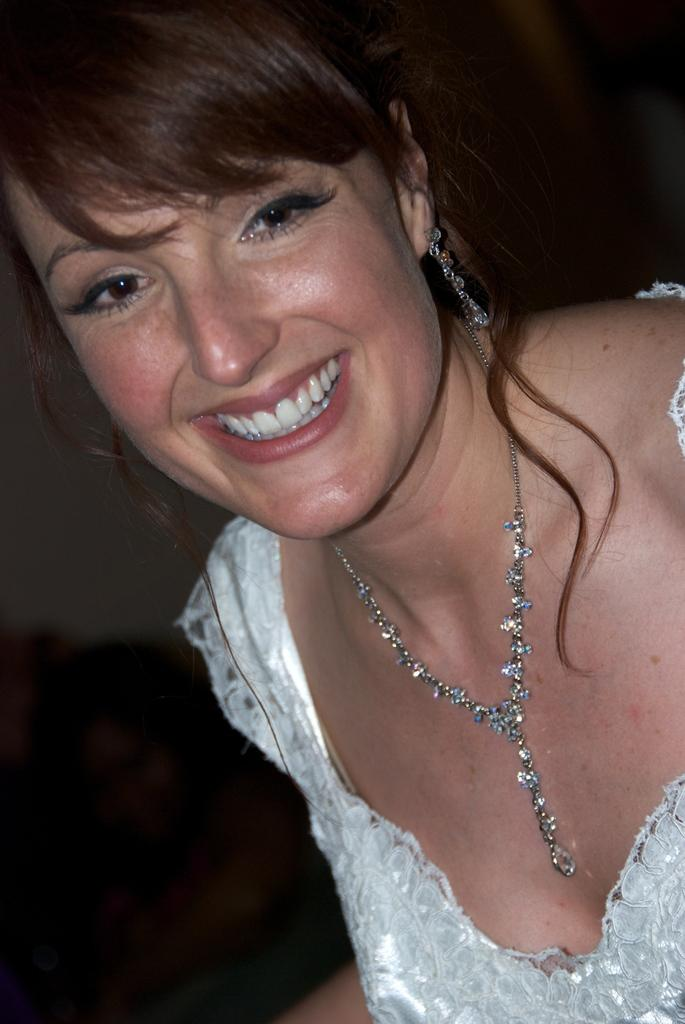Who is present in the image? There is a woman in the image. What is the woman doing in the image? The woman is smiling. Can you tell me how the earthquake affected the woman's sister in the yard in the image? There is no mention of an earthquake, a sister, or a yard in the image. The image only features a woman who is smiling. 